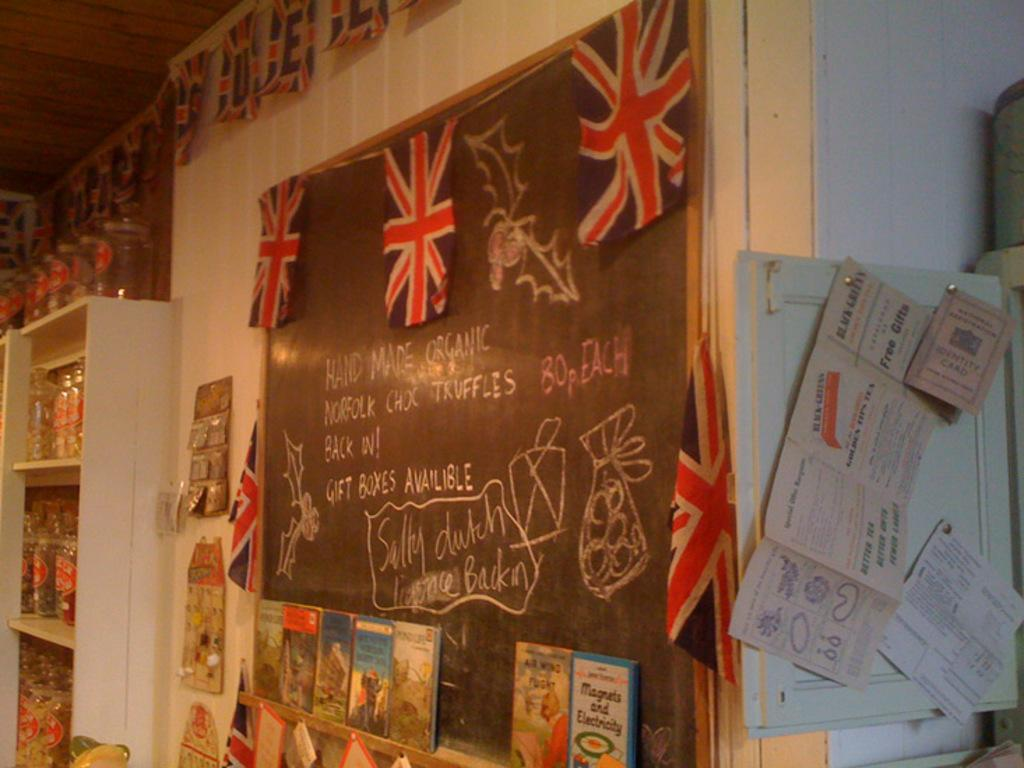<image>
Give a short and clear explanation of the subsequent image. If you are looking for HAND MADE ORGANIC NORFOLK CHOC TRUFFLES, they're BACK IN! 